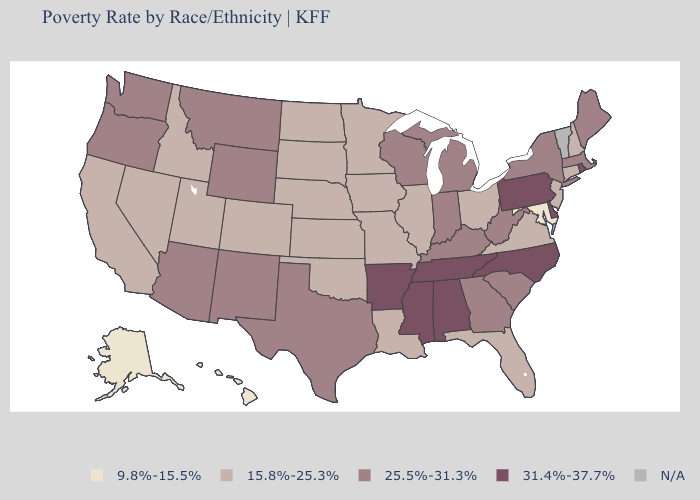What is the highest value in the South ?
Be succinct. 31.4%-37.7%. What is the highest value in states that border Kentucky?
Give a very brief answer. 31.4%-37.7%. What is the highest value in states that border Montana?
Answer briefly. 25.5%-31.3%. What is the value of Wyoming?
Concise answer only. 25.5%-31.3%. What is the highest value in the USA?
Short answer required. 31.4%-37.7%. What is the value of Arizona?
Short answer required. 25.5%-31.3%. What is the value of Florida?
Give a very brief answer. 15.8%-25.3%. Name the states that have a value in the range 9.8%-15.5%?
Write a very short answer. Alaska, Hawaii, Maryland. Does the first symbol in the legend represent the smallest category?
Be succinct. Yes. Does Idaho have the highest value in the West?
Give a very brief answer. No. What is the highest value in the USA?
Short answer required. 31.4%-37.7%. What is the value of Mississippi?
Short answer required. 31.4%-37.7%. Does Maryland have the lowest value in the South?
Write a very short answer. Yes. What is the value of Virginia?
Give a very brief answer. 15.8%-25.3%. 